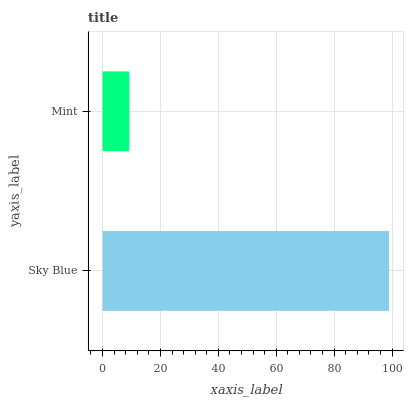Is Mint the minimum?
Answer yes or no. Yes. Is Sky Blue the maximum?
Answer yes or no. Yes. Is Mint the maximum?
Answer yes or no. No. Is Sky Blue greater than Mint?
Answer yes or no. Yes. Is Mint less than Sky Blue?
Answer yes or no. Yes. Is Mint greater than Sky Blue?
Answer yes or no. No. Is Sky Blue less than Mint?
Answer yes or no. No. Is Sky Blue the high median?
Answer yes or no. Yes. Is Mint the low median?
Answer yes or no. Yes. Is Mint the high median?
Answer yes or no. No. Is Sky Blue the low median?
Answer yes or no. No. 